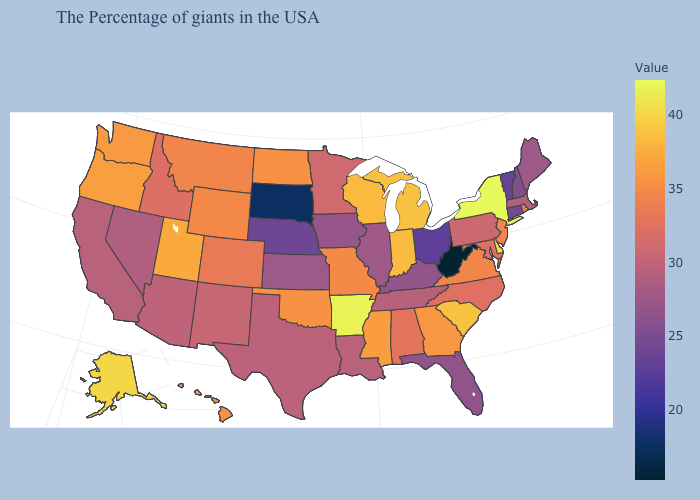Which states have the highest value in the USA?
Quick response, please. New York. Which states have the lowest value in the USA?
Answer briefly. West Virginia. Which states hav the highest value in the South?
Keep it brief. Arkansas. Does Nevada have the lowest value in the West?
Concise answer only. Yes. Which states have the lowest value in the MidWest?
Keep it brief. South Dakota. Among the states that border Arkansas , which have the lowest value?
Answer briefly. Tennessee. 